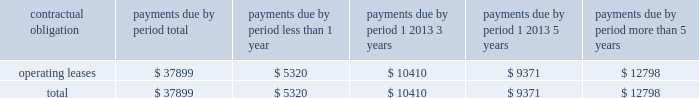As of december 31 , 2006 , we also leased an office and laboratory facility in connecticut , additional office , distribution and storage facilities in san diego , and four foreign facilities located in japan , singapore , china and the netherlands under non-cancelable operating leases that expire at various times through july 2011 .
These leases contain renewal options ranging from one to five years .
As of december 31 , 2006 , our contractual obligations were ( in thousands ) : contractual obligation total less than 1 year 1 2013 3 years 1 2013 5 years more than 5 years .
The above table does not include orders for goods and services entered into in the normal course of business that are not enforceable or legally binding .
Item 7a .
Quantitative and qualitative disclosures about market risk .
Interest rate sensitivity our exposure to market risk for changes in interest rates relates primarily to our investment portfolio .
The fair market value of fixed rate securities may be adversely impacted by fluctuations in interest rates while income earned on floating rate securities may decline as a result of decreases in interest rates .
Under our current policies , we do not use interest rate derivative instruments to manage exposure to interest rate changes .
We attempt to ensure the safety and preservation of our invested principal funds by limiting default risk , market risk and reinvestment risk .
We mitigate default risk by investing in investment grade securities .
We have historically maintained a relatively short average maturity for our investment portfolio , and we believe a hypothetical 100 basis point adverse move in interest rates along the entire interest rate yield curve would not materially affect the fair value of our interest sensitive financial instruments .
Foreign currency exchange risk although most of our revenue is realized in u.s .
Dollars , some portions of our revenue are realized in foreign currencies .
As a result , our financial results could be affected by factors such as changes in foreign currency exchange rates or weak economic conditions in foreign markets .
The functional currencies of our subsidiaries are their respective local currencies .
Accordingly , the accounts of these operations are translated from the local currency to the u.s .
Dollar using the current exchange rate in effect at the balance sheet date for the balance sheet accounts , and using the average exchange rate during the period for revenue and expense accounts .
The effects of translation are recorded in accumulated other comprehensive income as a separate component of stockholders 2019 equity. .
What percentage of total contractual obligations are due in less than one year? 
Computations: (5320 / 37899)
Answer: 0.14037. 